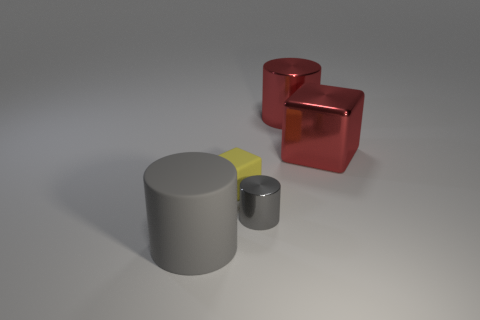Subtract all red cylinders. How many cylinders are left? 2 Subtract 3 cylinders. How many cylinders are left? 0 Subtract 0 purple blocks. How many objects are left? 5 Subtract all cylinders. How many objects are left? 2 Subtract all cyan blocks. Subtract all gray cylinders. How many blocks are left? 2 Subtract all green blocks. How many gray cylinders are left? 2 Subtract all large green metallic cubes. Subtract all tiny gray metallic objects. How many objects are left? 4 Add 5 gray metallic things. How many gray metallic things are left? 6 Add 4 large red shiny objects. How many large red shiny objects exist? 6 Add 2 small rubber things. How many objects exist? 7 